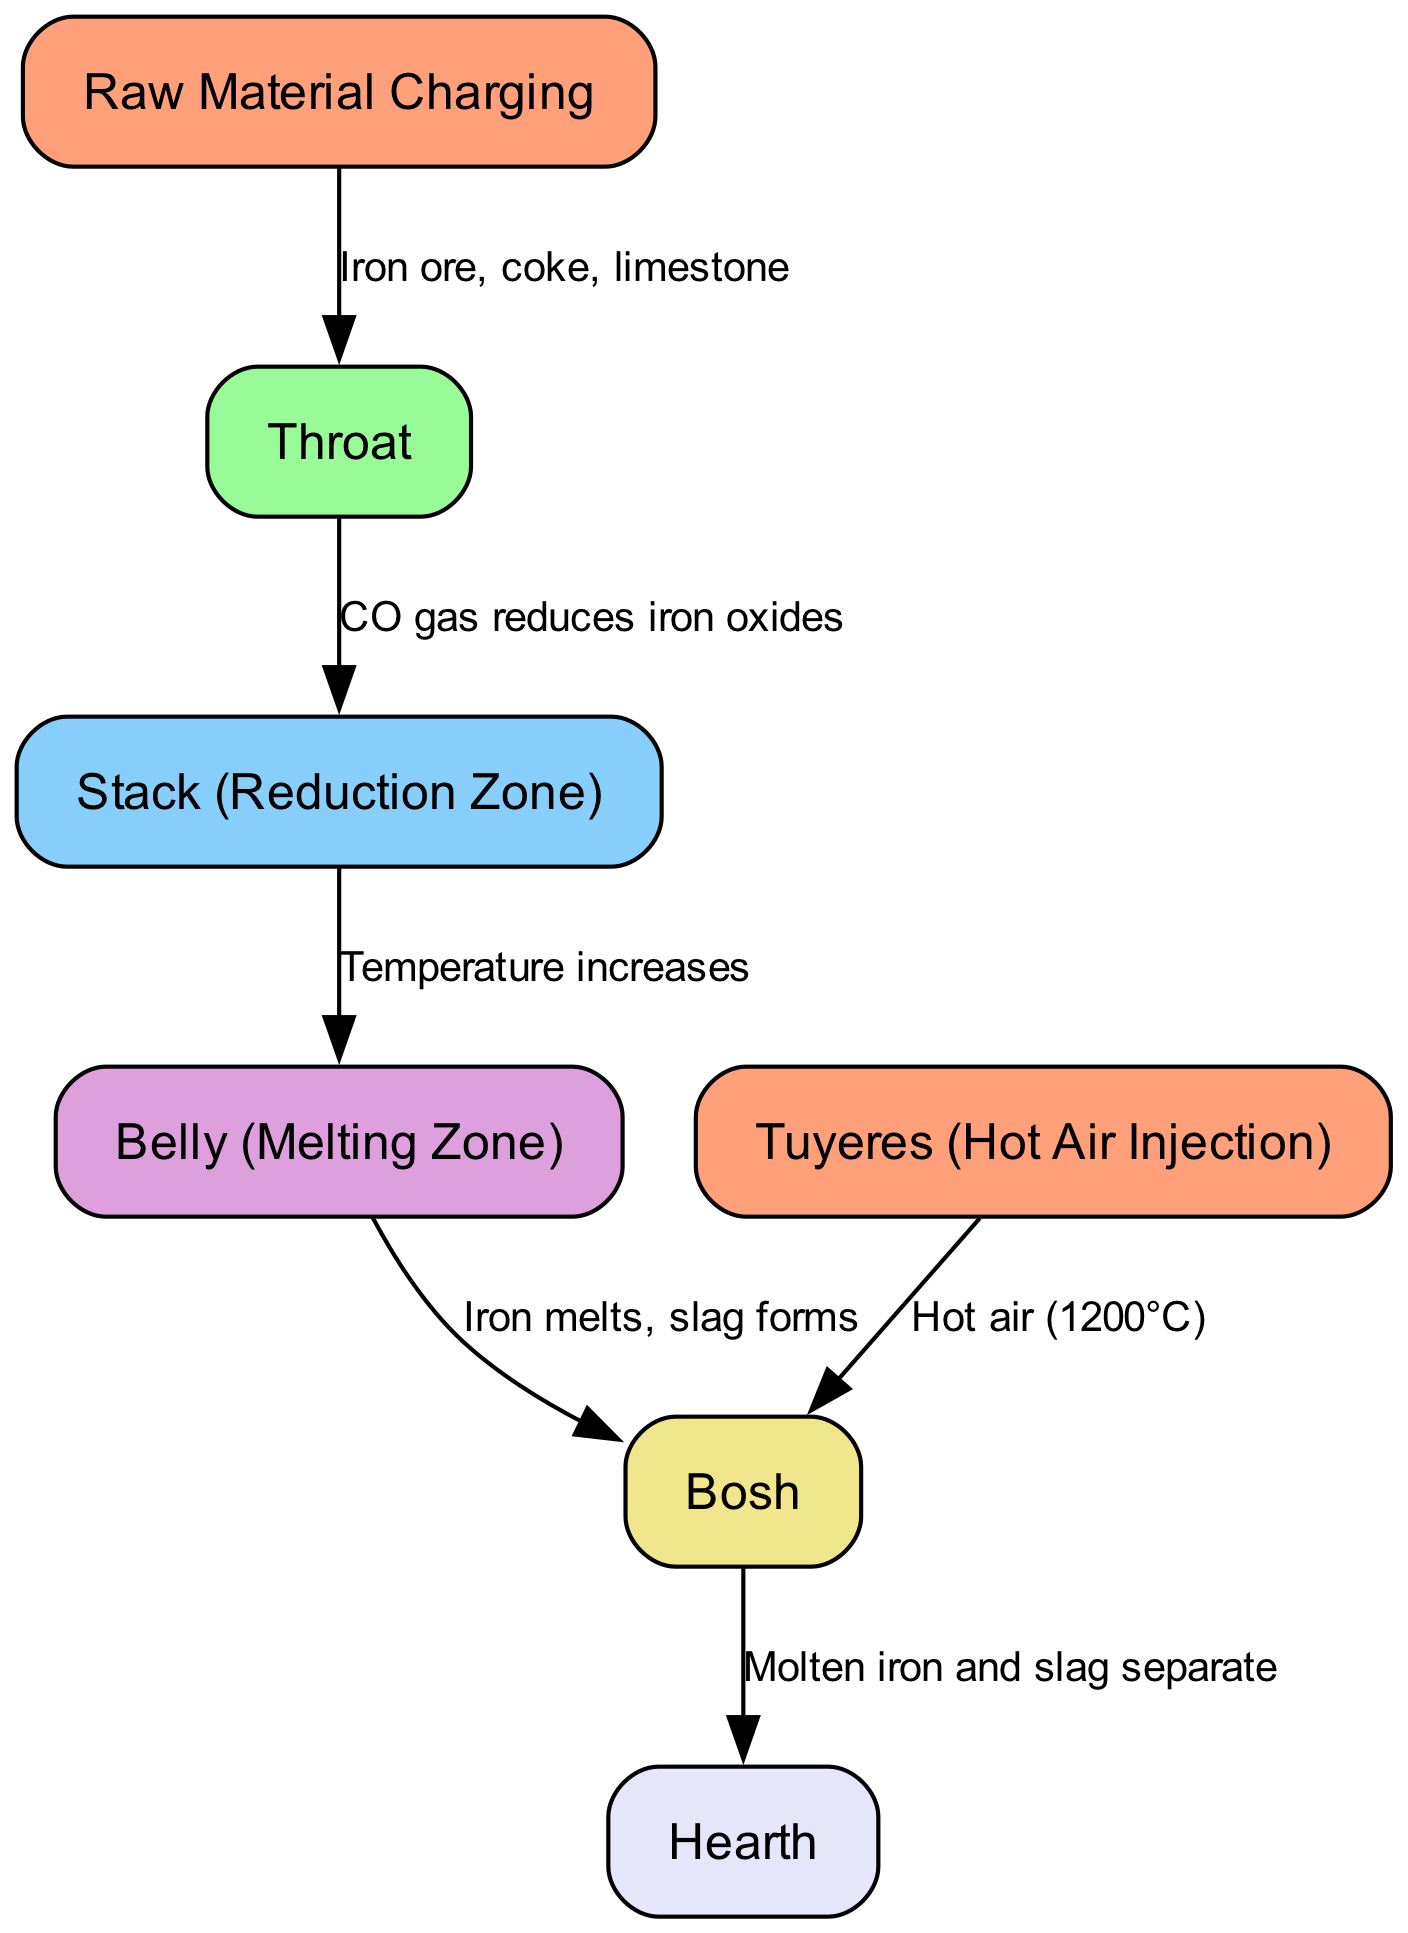What is the highest node in the diagram? The highest node represents the initial phase of the process, which is "Raw Material Charging." This is identified as the first node listed in the data.
Answer: Raw Material Charging How many nodes are present in the diagram? Counting all the nodes provided in the data section, there are seven nodes total.
Answer: 7 What does the throat link to? The throat node connects to the stack, which indicates the process transition from the throat to the reduction zone. The edge labeled provides the relationship.
Answer: Stack What is the chemical process occurring in the stack? The stack demonstrates a reduction process where carbon monoxide gas reduces iron oxides. This is indicated on the edge that connects the throat to the stack.
Answer: CO gas reduces iron oxides What temperature is provided by the tuyeres? The tuyeres inject hot air into the bosh at a temperature of 1200 degrees Celsius, as indicated on the edge linking the tuyeres to the bosh.
Answer: 1200°C What happens in the belly node? In the belly, the iron melts, and slag forms, as specified on the edge connecting the belly to the bosh. This indicates a critical transformation during the smelting process.
Answer: Iron melts, slag forms What is produced when the molten iron and slag separate? The last process in the diagram is the separation of molten iron and slag in the hearth, demonstrating the final outcome of the blast furnace operation.
Answer: Molten iron and slag separate How many edges are present in the diagram? By counting the connections (edges) listed in the edges section, we see there are a total of six edges representing the flow and relationships between nodes.
Answer: 6 What is the significance of the bosh in the diagram? The bosh serves as a crucial section of the furnace where iron melts and slag forms, marking it as an essential part of the smelting process. This is indicated in the edge leading from the belly to the bosh.
Answer: Melts iron and forms slag 